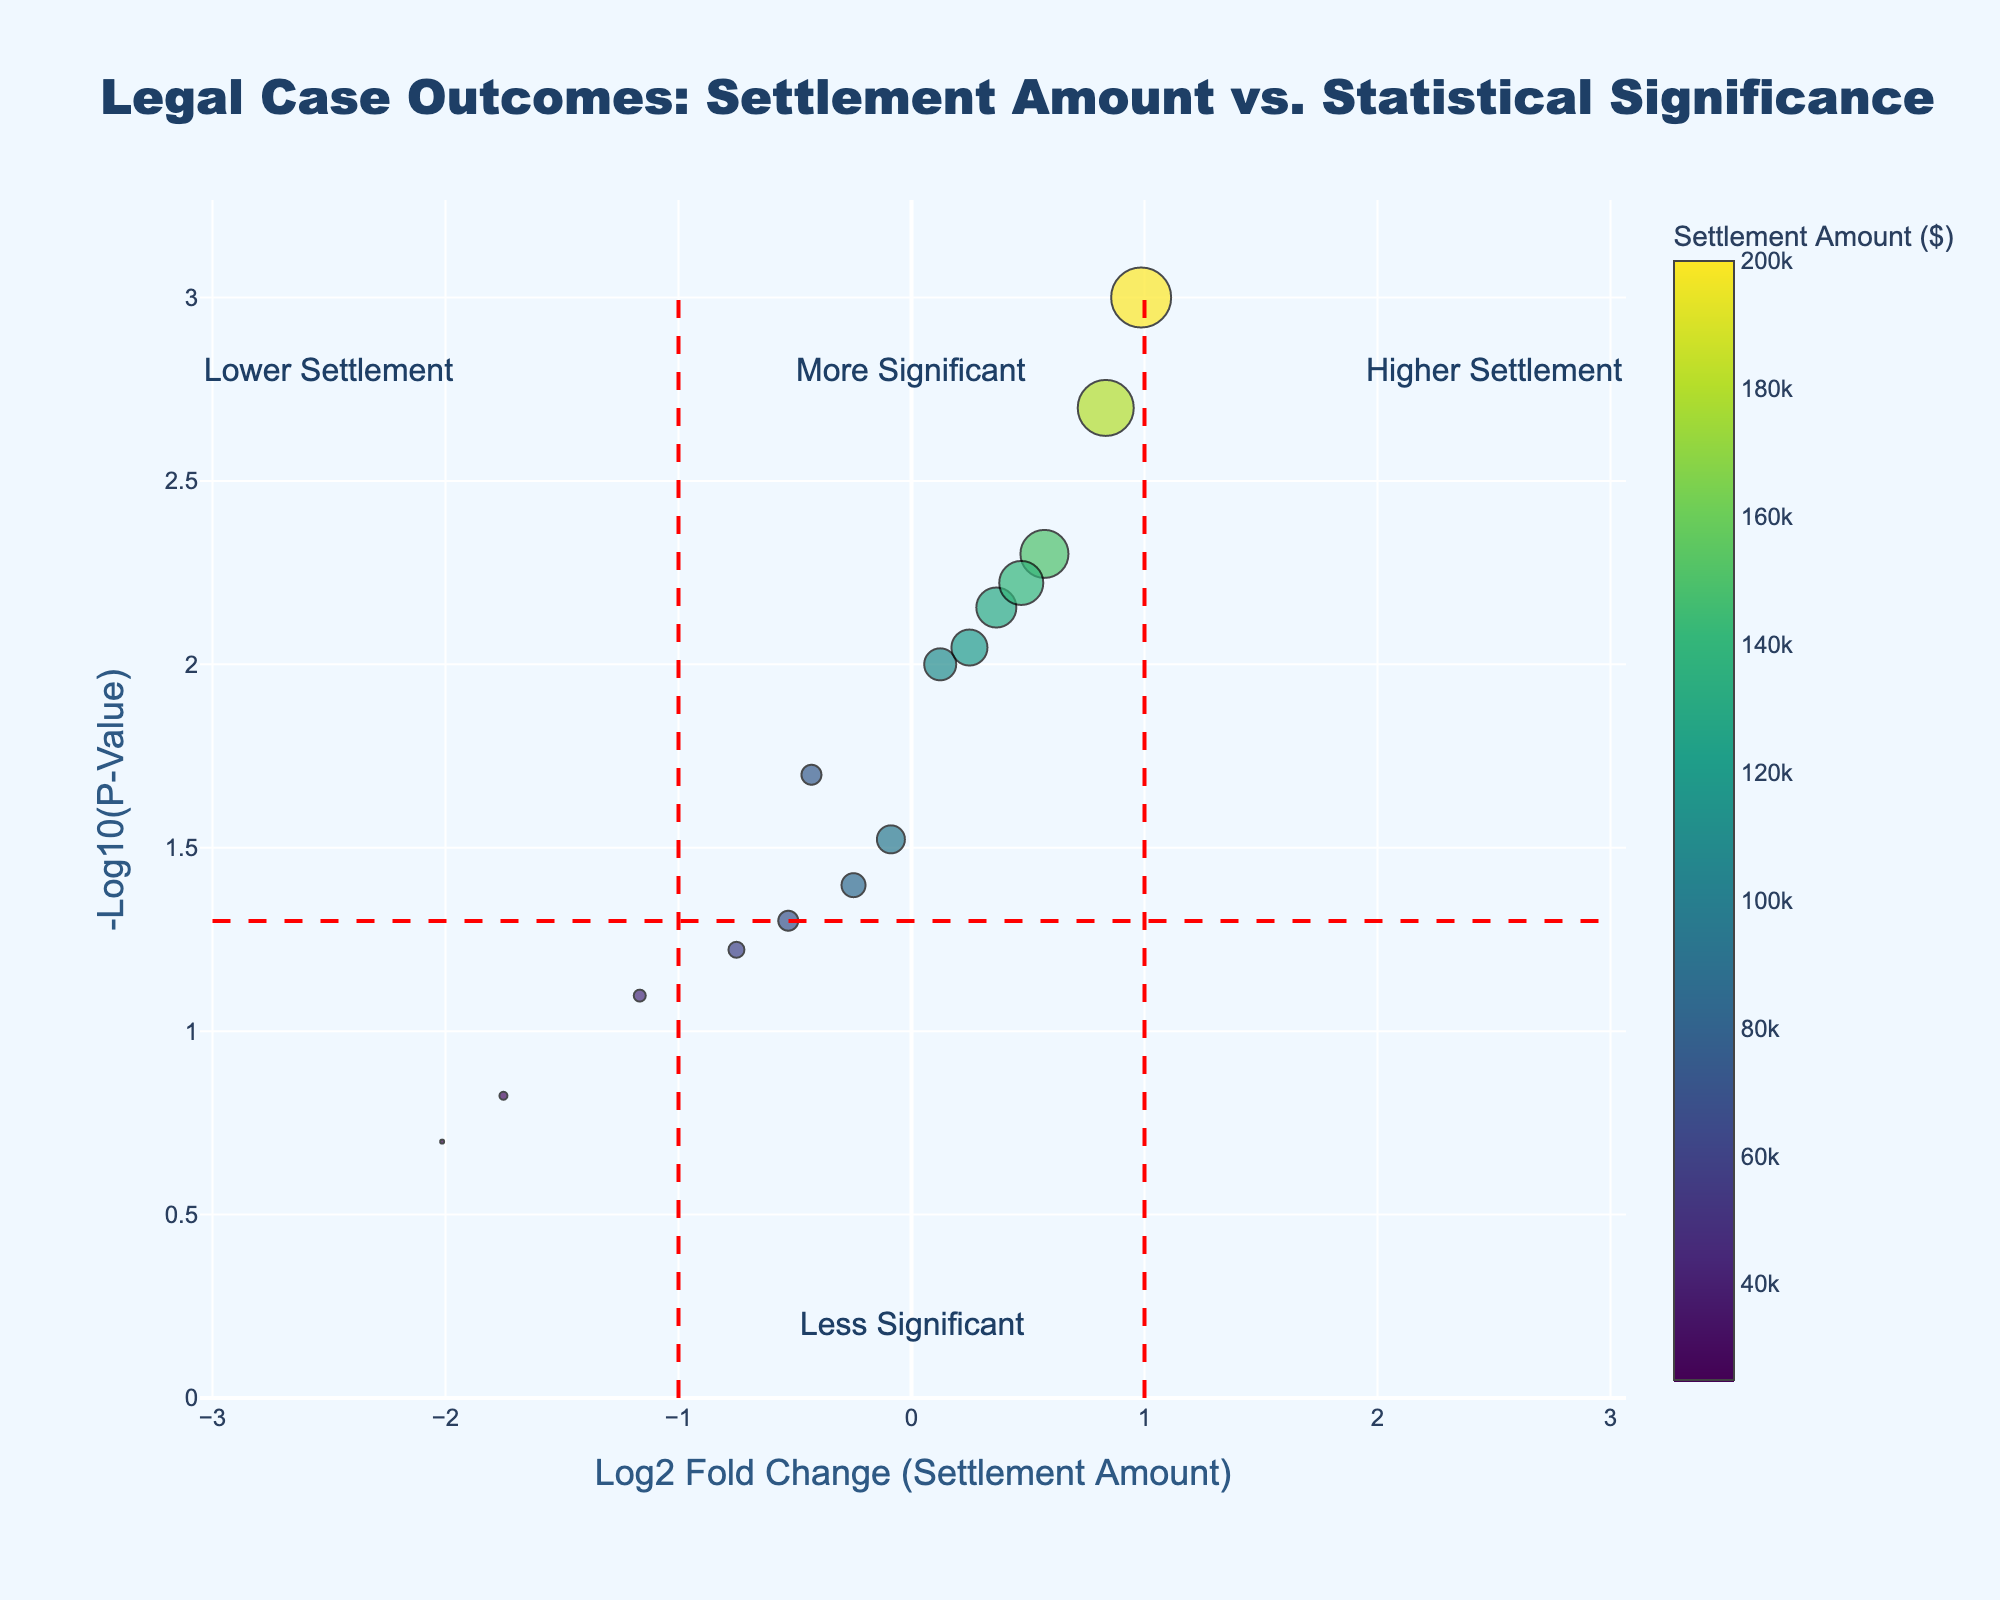What is the title of the plot? The title can be found at the top of the plot. It reads: "Legal Case Outcomes: Settlement Amount vs. Statistical Significance"
Answer: Legal Case Outcomes: Settlement Amount vs. Statistical Significance What are the labels for the x-axis and y-axis? The labels for the x-axis and y-axis are "Log2 Fold Change (Settlement Amount)" and "-Log10(P-Value)" respectively.
Answer: Log2 Fold Change (Settlement Amount), -Log10(P-Value) How many data points are there in the plot? By visually counting the markers in the scatter plot, there are 15 data points plotted.
Answer: 15 Which attorney secured the highest settlement amount? By referring to the color scale and hover text, Carter Defense has the highest settlement amount of $200,000.
Answer: Carter Defense Which data point indicates the lowest statistical significance? The lowest statistical significance corresponds to the smallest y-value on the plot. From the hover text, Oakwood Legal Team has the lowest significance with a p-value of 0.2 (closest to y-axis value 0.69897).
Answer: Oakwood Legal Team Which group of attorneys are considered to have more significant results? More significant results correspond to higher y-values (-log10(p-value)). Those above the horizontal red dashed line are considered more significant, i.e., everyone with y > 1.3.
Answer: Those above y = 1.3 What is the relationship between settlement amount and years of experience for attorneys with significant results? By looking at the hover text and the size (representing years of experience) and color (representing settlement amount) of the markers, attorneys with more years of experience tend to secure higher settlements and mostly fall into statistically significant results.
Answer: Positive correlation Which attorney had a significant result but less-than-average settlement amount? The average settlement amount is the midpoint of the color bar (around $106,667). Johnson & Associates with a settlement amount of $75,000 and a statistically significant result (p-value 0.02) falls into this category.
Answer: Johnson & Associates If an attorney's x-value is approximately 1, what does that indicate about their case's settlement amount? An x-value of 1 means the settlement amount is about 2 times the average settlement amount, considering x is the log base 2 fold change.
Answer: About twice the mean settlement amount What do the vertical red dashed lines on the plot indicate? The vertical red dashed lines indicate boundaries for log2 fold change at -1 and 1, generally highlighting significant shifts in settlement amounts from the average.
Answer: Boundaries for significant fold change 